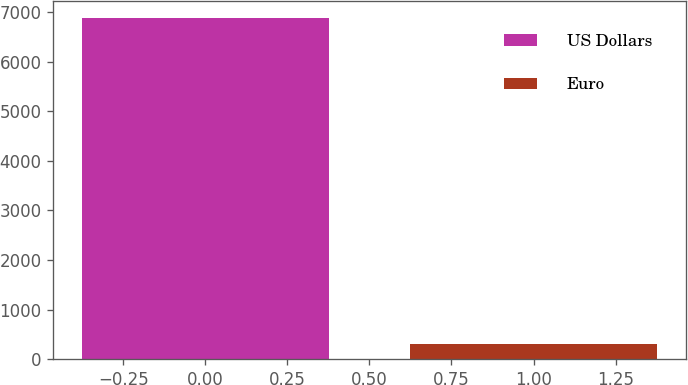<chart> <loc_0><loc_0><loc_500><loc_500><bar_chart><fcel>US Dollars<fcel>Euro<nl><fcel>6891<fcel>305<nl></chart> 